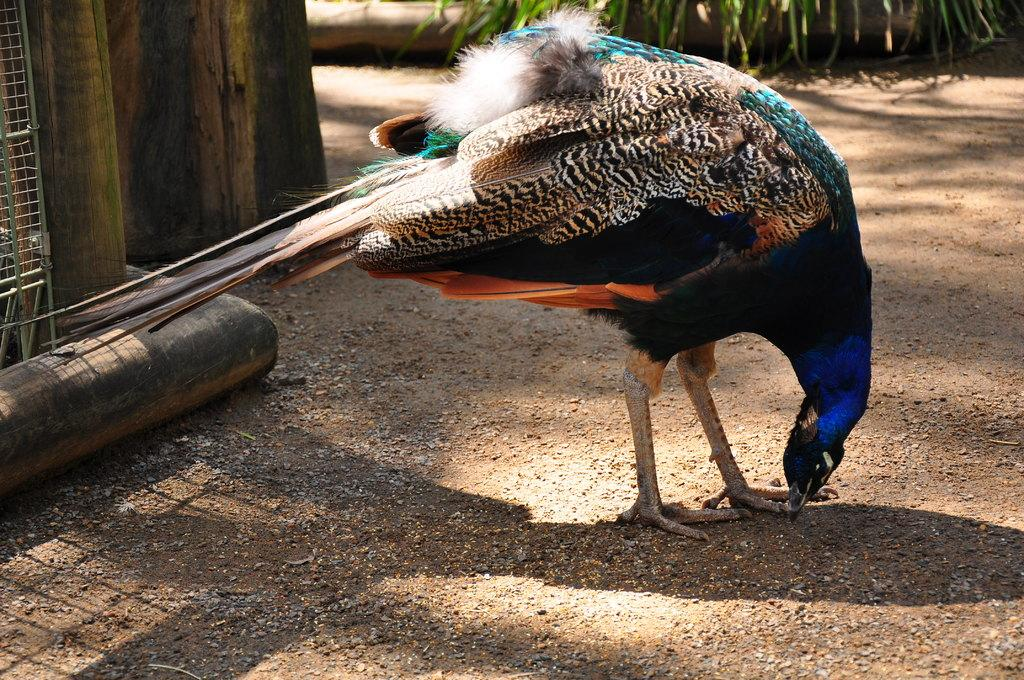What is the main subject in the middle of the image? There is a peacock in the middle of the image. What can be seen on the left side of the image? There is a pipe and a fence on the left side of the image. What type of music is the peacock playing in the image? There is no music or indication of music in the image; the peacock is simply standing in the middle of the image. 